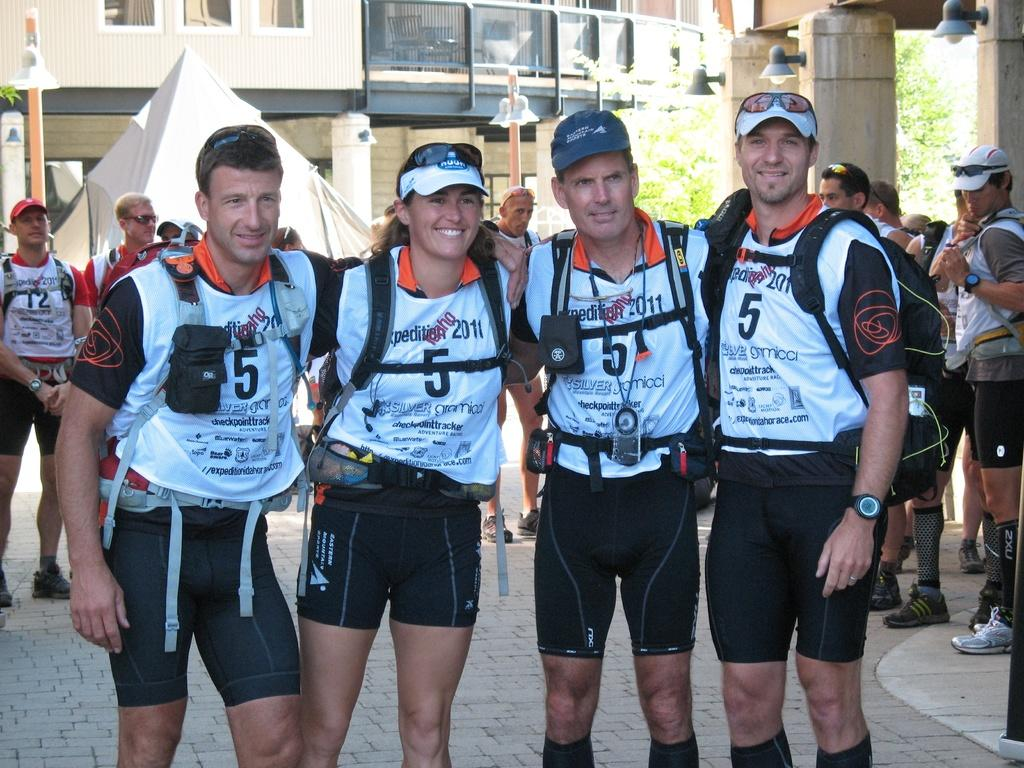What are the people in the image doing? The people in the image are standing and carrying bags. What accessories are the people wearing in the image? The people are wearing caps and goggles in the image. What can be seen in the background of the image? There are buildings, lights, and pillars in the background of the image. What type of glue is being used by the people in the image? There is no glue present in the image; the people are carrying bags and wearing caps and goggles. What type of wine can be seen in the image? There is no wine present in the image. 